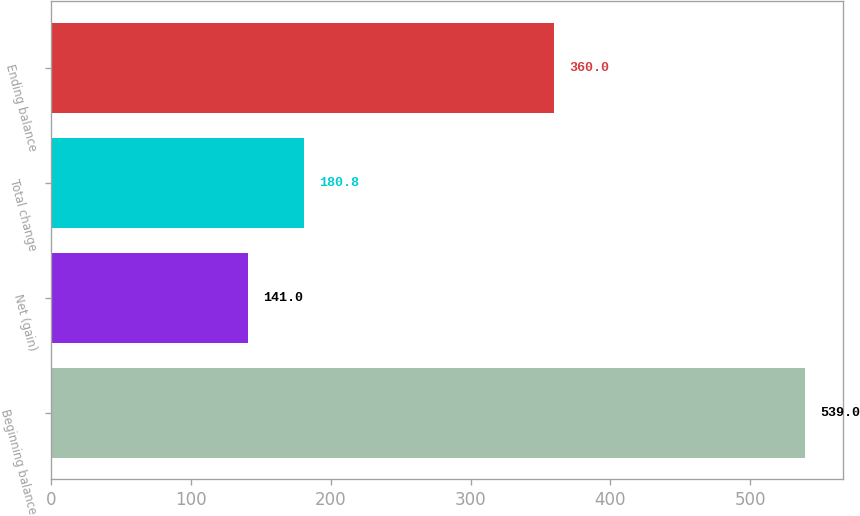Convert chart. <chart><loc_0><loc_0><loc_500><loc_500><bar_chart><fcel>Beginning balance<fcel>Net (gain)<fcel>Total change<fcel>Ending balance<nl><fcel>539<fcel>141<fcel>180.8<fcel>360<nl></chart> 